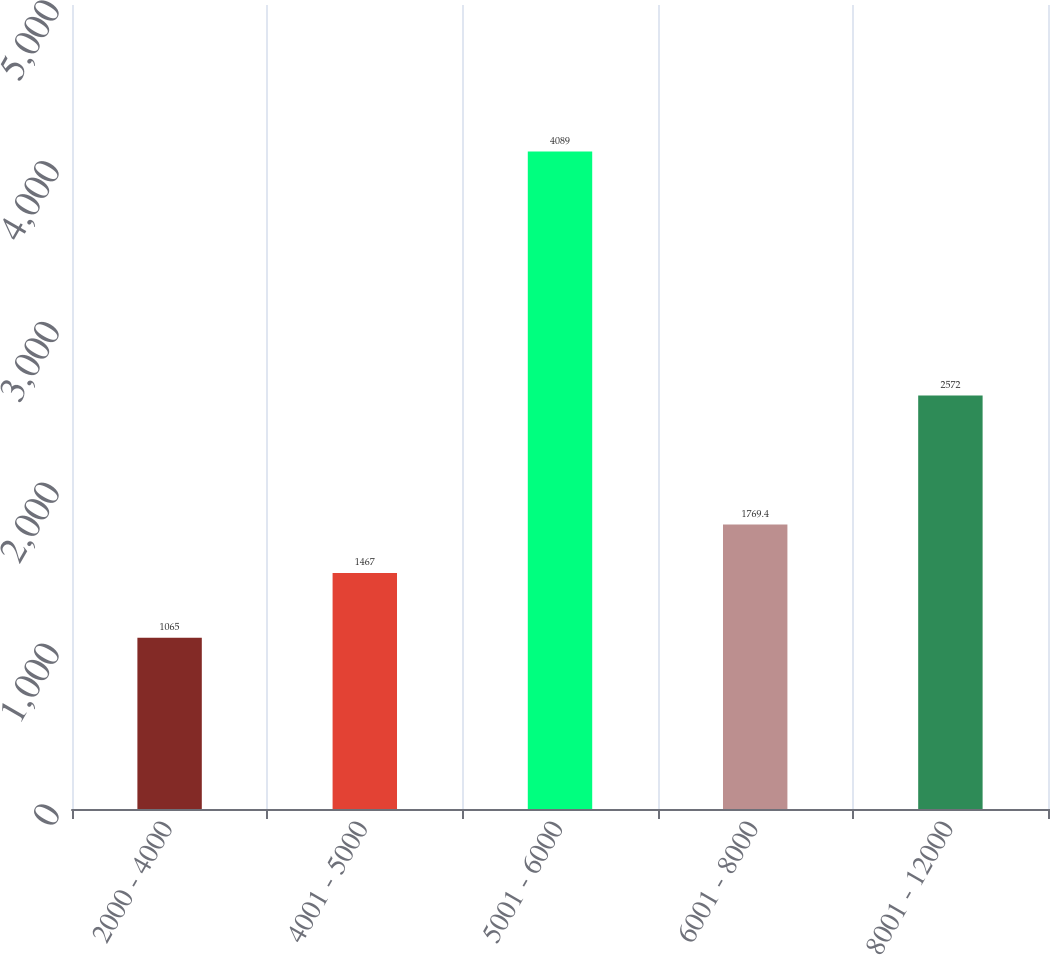<chart> <loc_0><loc_0><loc_500><loc_500><bar_chart><fcel>2000 - 4000<fcel>4001 - 5000<fcel>5001 - 6000<fcel>6001 - 8000<fcel>8001 - 12000<nl><fcel>1065<fcel>1467<fcel>4089<fcel>1769.4<fcel>2572<nl></chart> 